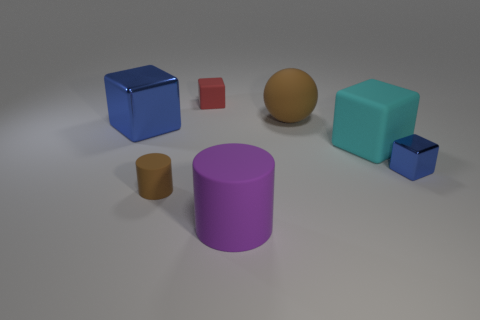What number of other things are there of the same size as the red object?
Make the answer very short. 2. There is a red thing that is left of the purple thing; does it have the same shape as the brown thing that is in front of the big shiny block?
Ensure brevity in your answer.  No. What number of big cyan objects are on the right side of the big cyan matte object?
Provide a short and direct response. 0. The metallic cube that is on the right side of the big blue metallic cube is what color?
Your answer should be very brief. Blue. The big object that is the same shape as the tiny brown object is what color?
Provide a short and direct response. Purple. Is there anything else that has the same color as the tiny metal object?
Provide a short and direct response. Yes. Are there more large brown matte things than cubes?
Ensure brevity in your answer.  No. Do the large blue object and the red cube have the same material?
Offer a very short reply. No. What number of large brown balls have the same material as the large cylinder?
Your answer should be very brief. 1. Do the brown matte cylinder and the blue block to the left of the large cyan matte thing have the same size?
Make the answer very short. No. 